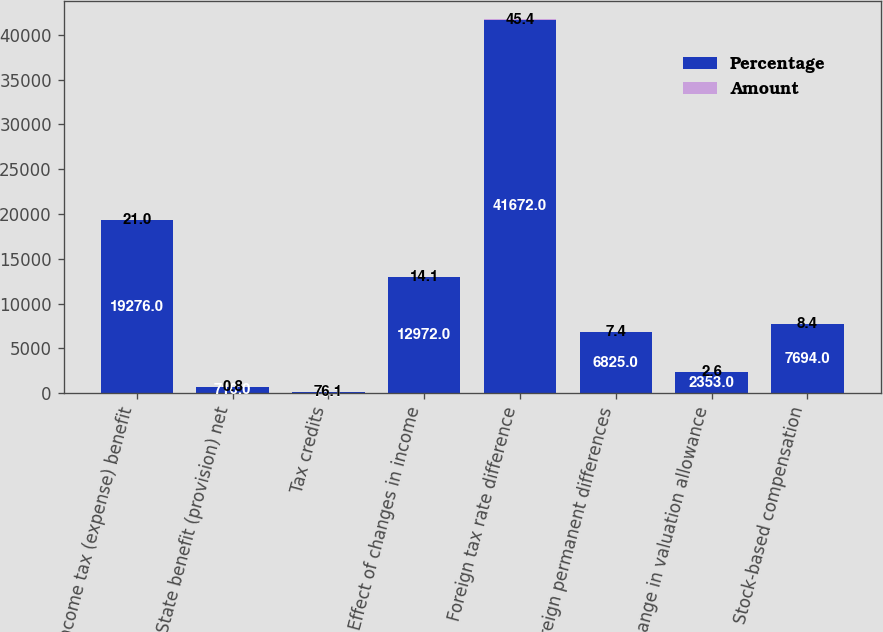Convert chart to OTSL. <chart><loc_0><loc_0><loc_500><loc_500><stacked_bar_chart><ecel><fcel>Income tax (expense) benefit<fcel>State benefit (provision) net<fcel>Tax credits<fcel>Effect of changes in income<fcel>Foreign tax rate difference<fcel>Foreign permanent differences<fcel>Change in valuation allowance<fcel>Stock-based compensation<nl><fcel>Percentage<fcel>19276<fcel>710<fcel>76.1<fcel>12972<fcel>41672<fcel>6825<fcel>2353<fcel>7694<nl><fcel>Amount<fcel>21<fcel>0.8<fcel>76.1<fcel>14.1<fcel>45.4<fcel>7.4<fcel>2.6<fcel>8.4<nl></chart> 